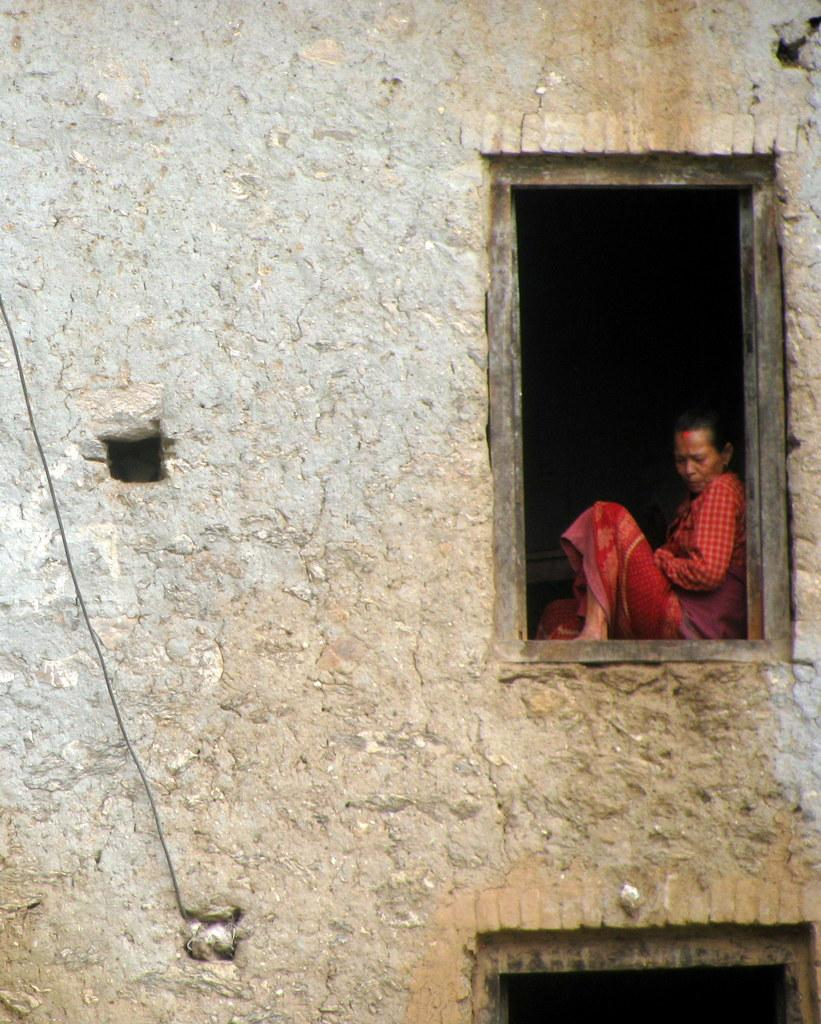What type of structure is present in the image? There is a building in the image. Can you describe what is visible inside the building? A woman is visible through a window in the building. What can be seen on the left side of the image? There is a black color wire on the left side of the image. What type of prison is depicted in the image? There is no prison present in the image; it features a building with a woman visible through a window and a black color wire on the left side. 